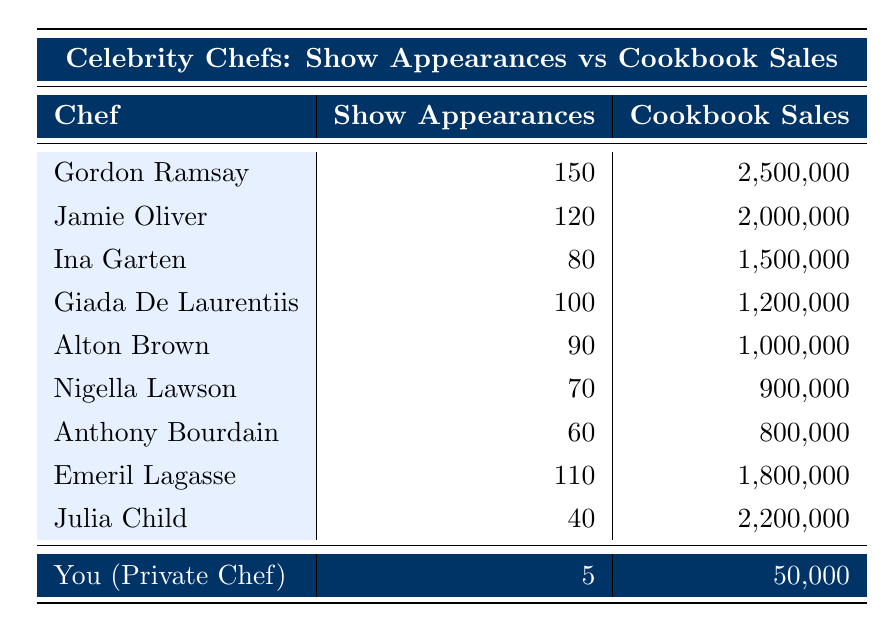What is the total number of cooking show appearances by all chefs combined? To find the total, we can sum the cooking show appearances of each chef: 150 + 120 + 80 + 100 + 90 + 70 + 60 + 110 + 40 + 5 = 1025.
Answer: 1025 Which chef has the highest cookbook sales? By comparing the cookbook sales listed, Gordon Ramsay has the highest sales at 2,500,000.
Answer: Gordon Ramsay What is the average number of cooking show appearances among the chefs? To calculate the average, we sum the appearances (1025) and divide by the number of chefs (10): 1025 / 10 = 102.5.
Answer: 102.5 Is there a correlation between cooking show appearances and cookbook sales? Observing the data, higher show appearances often correlate with higher cookbook sales, particularly for chefs like Gordon Ramsay.
Answer: Yes What is the difference in cookbook sales between Gordon Ramsay and Julia Child? Gordon Ramsay's sales are 2,500,000 and Julia Child's are 2,200,000. The difference is 2,500,000 - 2,200,000 = 300,000.
Answer: 300,000 Which chef has the most show appearances along with sales surpassing 1 million? The chefs with appearances above 100 and sales over 1 million are Gordon Ramsay, Jamie Oliver, Emeril Lagasse, and Giada De Laurentiis. Among them, Gordon Ramsay has the most appearances at 150.
Answer: Gordon Ramsay What is the ratio of cooking show appearances to cookbook sales for Nigella Lawson? For Nigella Lawson, the appearances are 70, and the sales are 900,000. The ratio is 70 / 900,000.
Answer: 0.0000778 How many chefs have cookbook sales of less than 1 million? Checking the sales data, we find that Nigella Lawson (900,000) and Anthony Bourdain (800,000) are the only chefs under 1 million, totaling 2 chefs.
Answer: 2 What is the median number of cookbook sales among the chefs listed? To find the median, we first list the sales in order: 50,000; 800,000; 900,000; 1,000,000; 1,200,000; 1,500,000; 1,800,000; 2,000,000; 2,200,000; 2,500,000. The median is the average of the 5th and 6th values: (1,500,000 + 1,800,000) / 2 = 1,650,000.
Answer: 1,650,000 What percentage of total cookbook sales does Anthony Bourdain's sales represent? The total cookbook sales are 9,750,000 (sum of all). Bourdain’s sales are 800,000. The percentage is (800,000 / 9,750,000) * 100 ≈ 8.2%.
Answer: 8.2% 